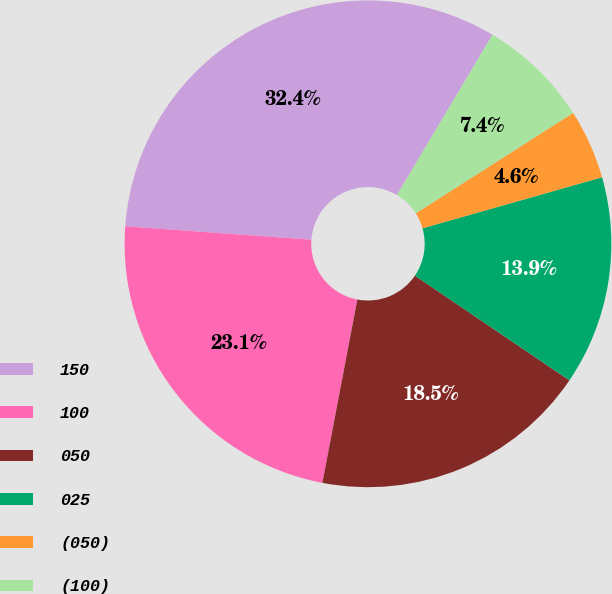Convert chart to OTSL. <chart><loc_0><loc_0><loc_500><loc_500><pie_chart><fcel>150<fcel>100<fcel>050<fcel>025<fcel>(050)<fcel>(100)<nl><fcel>32.41%<fcel>23.15%<fcel>18.52%<fcel>13.89%<fcel>4.63%<fcel>7.41%<nl></chart> 